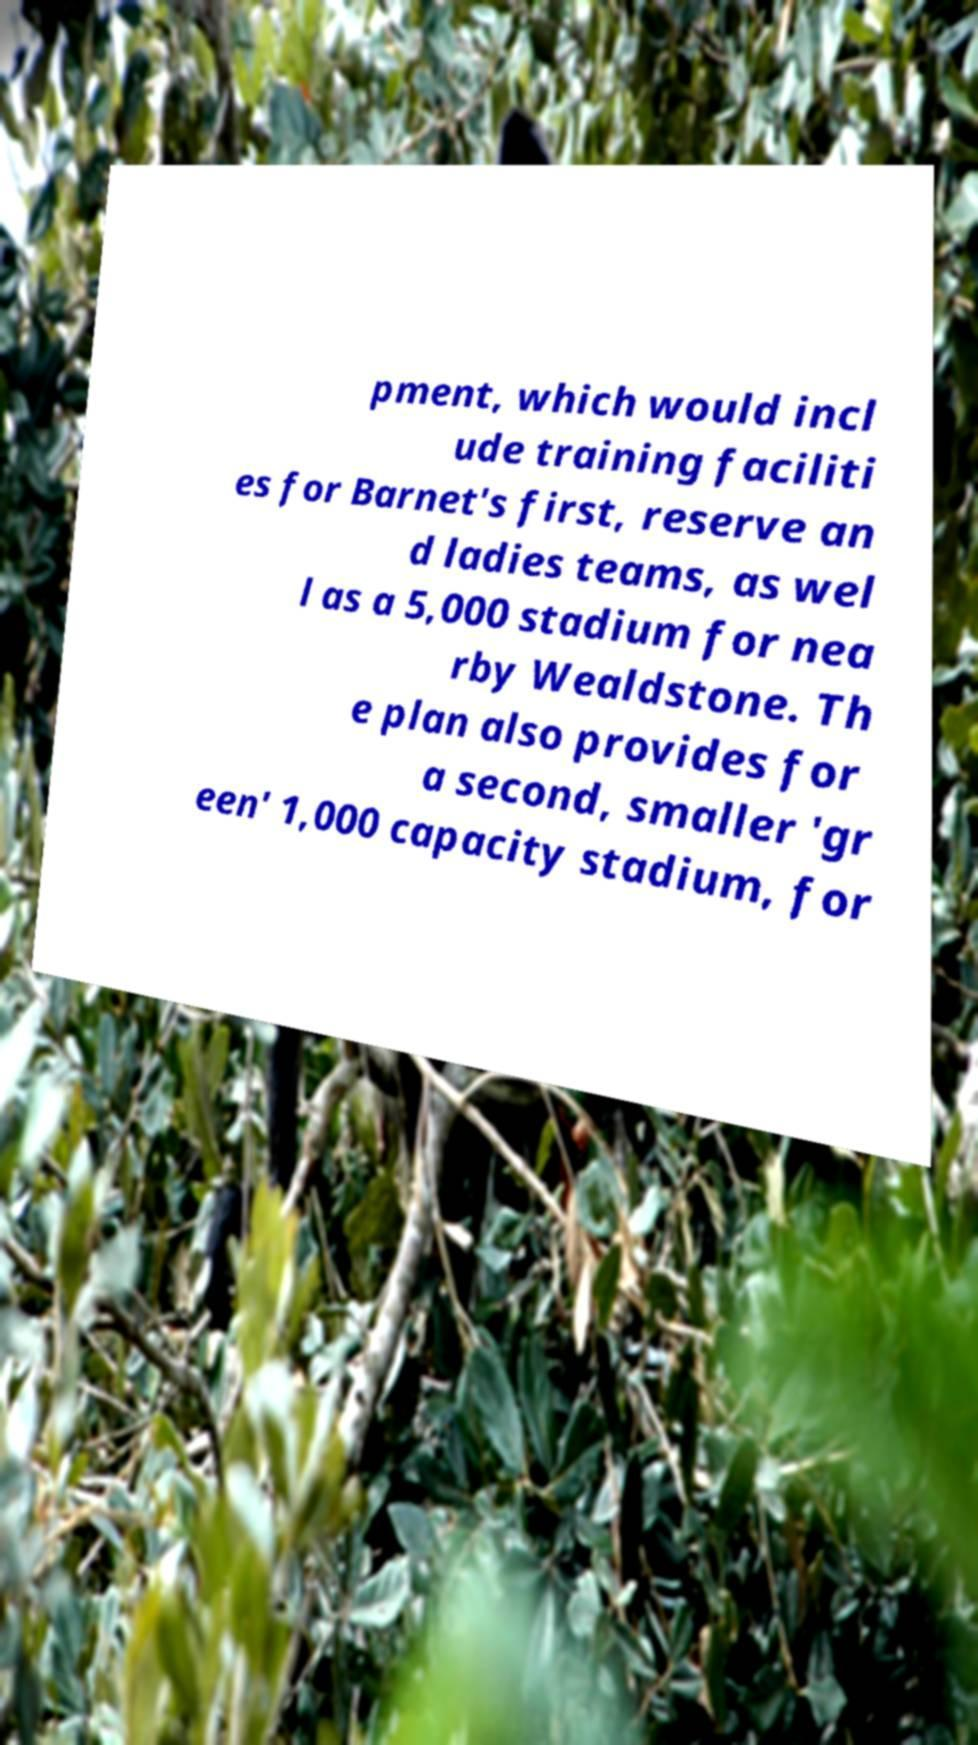Can you accurately transcribe the text from the provided image for me? pment, which would incl ude training faciliti es for Barnet's first, reserve an d ladies teams, as wel l as a 5,000 stadium for nea rby Wealdstone. Th e plan also provides for a second, smaller 'gr een' 1,000 capacity stadium, for 